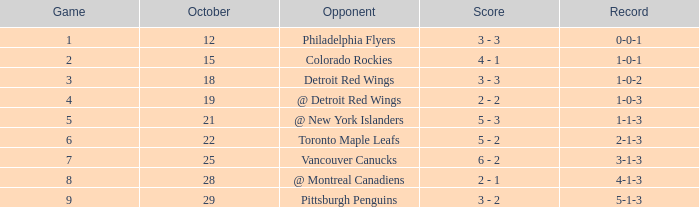What is the score of the game that happened before october 28 and had more than 6 points? 6 - 2. 